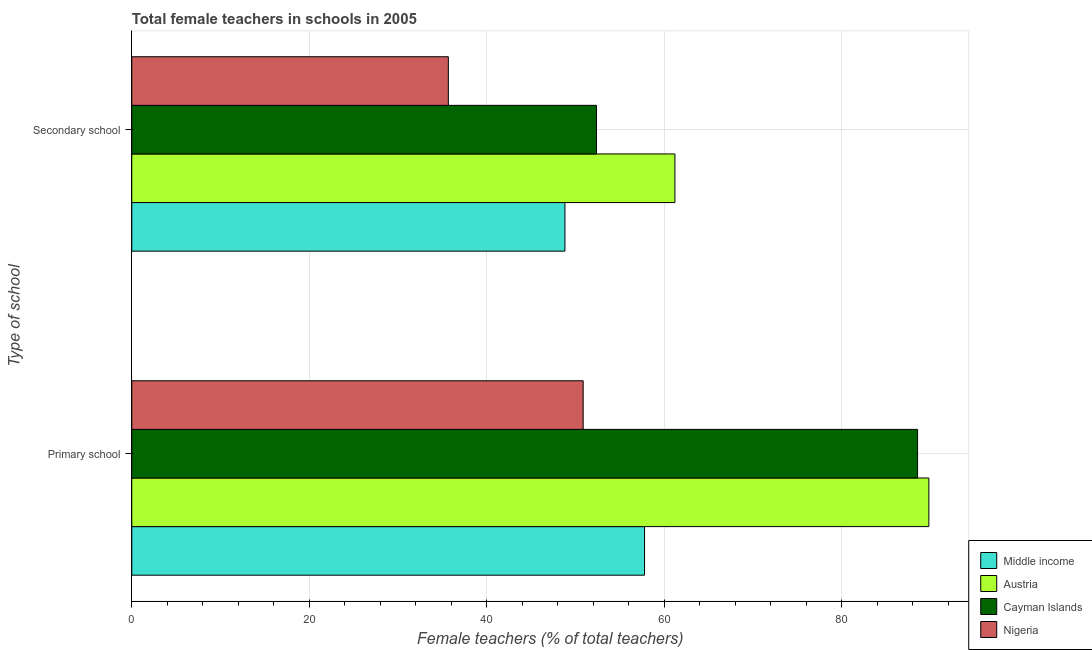How many groups of bars are there?
Offer a terse response. 2. Are the number of bars per tick equal to the number of legend labels?
Provide a succinct answer. Yes. How many bars are there on the 1st tick from the top?
Your answer should be compact. 4. What is the label of the 1st group of bars from the top?
Offer a terse response. Secondary school. What is the percentage of female teachers in primary schools in Nigeria?
Your answer should be compact. 50.86. Across all countries, what is the maximum percentage of female teachers in primary schools?
Offer a terse response. 89.81. Across all countries, what is the minimum percentage of female teachers in primary schools?
Provide a short and direct response. 50.86. In which country was the percentage of female teachers in primary schools minimum?
Provide a succinct answer. Nigeria. What is the total percentage of female teachers in primary schools in the graph?
Ensure brevity in your answer.  286.98. What is the difference between the percentage of female teachers in secondary schools in Middle income and that in Nigeria?
Offer a terse response. 13.14. What is the difference between the percentage of female teachers in secondary schools in Cayman Islands and the percentage of female teachers in primary schools in Nigeria?
Keep it short and to the point. 1.5. What is the average percentage of female teachers in secondary schools per country?
Provide a short and direct response. 49.51. What is the difference between the percentage of female teachers in secondary schools and percentage of female teachers in primary schools in Nigeria?
Offer a terse response. -15.19. In how many countries, is the percentage of female teachers in primary schools greater than 20 %?
Offer a very short reply. 4. What is the ratio of the percentage of female teachers in secondary schools in Nigeria to that in Cayman Islands?
Your response must be concise. 0.68. In how many countries, is the percentage of female teachers in primary schools greater than the average percentage of female teachers in primary schools taken over all countries?
Ensure brevity in your answer.  2. What does the 1st bar from the top in Secondary school represents?
Provide a succinct answer. Nigeria. How many countries are there in the graph?
Keep it short and to the point. 4. What is the difference between two consecutive major ticks on the X-axis?
Make the answer very short. 20. Does the graph contain grids?
Your response must be concise. Yes. How many legend labels are there?
Offer a very short reply. 4. What is the title of the graph?
Ensure brevity in your answer.  Total female teachers in schools in 2005. What is the label or title of the X-axis?
Your response must be concise. Female teachers (% of total teachers). What is the label or title of the Y-axis?
Provide a succinct answer. Type of school. What is the Female teachers (% of total teachers) in Middle income in Primary school?
Your response must be concise. 57.77. What is the Female teachers (% of total teachers) in Austria in Primary school?
Ensure brevity in your answer.  89.81. What is the Female teachers (% of total teachers) in Cayman Islands in Primary school?
Make the answer very short. 88.54. What is the Female teachers (% of total teachers) of Nigeria in Primary school?
Ensure brevity in your answer.  50.86. What is the Female teachers (% of total teachers) in Middle income in Secondary school?
Provide a succinct answer. 48.81. What is the Female teachers (% of total teachers) of Austria in Secondary school?
Make the answer very short. 61.2. What is the Female teachers (% of total teachers) in Cayman Islands in Secondary school?
Keep it short and to the point. 52.36. What is the Female teachers (% of total teachers) in Nigeria in Secondary school?
Offer a terse response. 35.67. Across all Type of school, what is the maximum Female teachers (% of total teachers) in Middle income?
Your response must be concise. 57.77. Across all Type of school, what is the maximum Female teachers (% of total teachers) in Austria?
Make the answer very short. 89.81. Across all Type of school, what is the maximum Female teachers (% of total teachers) of Cayman Islands?
Offer a very short reply. 88.54. Across all Type of school, what is the maximum Female teachers (% of total teachers) of Nigeria?
Keep it short and to the point. 50.86. Across all Type of school, what is the minimum Female teachers (% of total teachers) of Middle income?
Your answer should be compact. 48.81. Across all Type of school, what is the minimum Female teachers (% of total teachers) of Austria?
Offer a terse response. 61.2. Across all Type of school, what is the minimum Female teachers (% of total teachers) in Cayman Islands?
Your answer should be very brief. 52.36. Across all Type of school, what is the minimum Female teachers (% of total teachers) of Nigeria?
Your response must be concise. 35.67. What is the total Female teachers (% of total teachers) in Middle income in the graph?
Make the answer very short. 106.58. What is the total Female teachers (% of total teachers) of Austria in the graph?
Offer a very short reply. 151.01. What is the total Female teachers (% of total teachers) of Cayman Islands in the graph?
Your answer should be very brief. 140.9. What is the total Female teachers (% of total teachers) in Nigeria in the graph?
Give a very brief answer. 86.53. What is the difference between the Female teachers (% of total teachers) of Middle income in Primary school and that in Secondary school?
Keep it short and to the point. 8.97. What is the difference between the Female teachers (% of total teachers) in Austria in Primary school and that in Secondary school?
Provide a succinct answer. 28.61. What is the difference between the Female teachers (% of total teachers) in Cayman Islands in Primary school and that in Secondary school?
Your response must be concise. 36.17. What is the difference between the Female teachers (% of total teachers) in Nigeria in Primary school and that in Secondary school?
Provide a succinct answer. 15.19. What is the difference between the Female teachers (% of total teachers) in Middle income in Primary school and the Female teachers (% of total teachers) in Austria in Secondary school?
Keep it short and to the point. -3.42. What is the difference between the Female teachers (% of total teachers) in Middle income in Primary school and the Female teachers (% of total teachers) in Cayman Islands in Secondary school?
Offer a terse response. 5.41. What is the difference between the Female teachers (% of total teachers) of Middle income in Primary school and the Female teachers (% of total teachers) of Nigeria in Secondary school?
Your answer should be compact. 22.11. What is the difference between the Female teachers (% of total teachers) in Austria in Primary school and the Female teachers (% of total teachers) in Cayman Islands in Secondary school?
Keep it short and to the point. 37.44. What is the difference between the Female teachers (% of total teachers) of Austria in Primary school and the Female teachers (% of total teachers) of Nigeria in Secondary school?
Provide a succinct answer. 54.14. What is the difference between the Female teachers (% of total teachers) in Cayman Islands in Primary school and the Female teachers (% of total teachers) in Nigeria in Secondary school?
Offer a terse response. 52.87. What is the average Female teachers (% of total teachers) in Middle income per Type of school?
Your answer should be very brief. 53.29. What is the average Female teachers (% of total teachers) of Austria per Type of school?
Provide a short and direct response. 75.5. What is the average Female teachers (% of total teachers) of Cayman Islands per Type of school?
Your answer should be very brief. 70.45. What is the average Female teachers (% of total teachers) of Nigeria per Type of school?
Your response must be concise. 43.26. What is the difference between the Female teachers (% of total teachers) of Middle income and Female teachers (% of total teachers) of Austria in Primary school?
Make the answer very short. -32.03. What is the difference between the Female teachers (% of total teachers) of Middle income and Female teachers (% of total teachers) of Cayman Islands in Primary school?
Your answer should be compact. -30.76. What is the difference between the Female teachers (% of total teachers) in Middle income and Female teachers (% of total teachers) in Nigeria in Primary school?
Provide a short and direct response. 6.91. What is the difference between the Female teachers (% of total teachers) in Austria and Female teachers (% of total teachers) in Cayman Islands in Primary school?
Provide a short and direct response. 1.27. What is the difference between the Female teachers (% of total teachers) of Austria and Female teachers (% of total teachers) of Nigeria in Primary school?
Make the answer very short. 38.95. What is the difference between the Female teachers (% of total teachers) in Cayman Islands and Female teachers (% of total teachers) in Nigeria in Primary school?
Keep it short and to the point. 37.68. What is the difference between the Female teachers (% of total teachers) of Middle income and Female teachers (% of total teachers) of Austria in Secondary school?
Offer a very short reply. -12.39. What is the difference between the Female teachers (% of total teachers) of Middle income and Female teachers (% of total teachers) of Cayman Islands in Secondary school?
Offer a very short reply. -3.56. What is the difference between the Female teachers (% of total teachers) in Middle income and Female teachers (% of total teachers) in Nigeria in Secondary school?
Keep it short and to the point. 13.14. What is the difference between the Female teachers (% of total teachers) of Austria and Female teachers (% of total teachers) of Cayman Islands in Secondary school?
Offer a terse response. 8.83. What is the difference between the Female teachers (% of total teachers) of Austria and Female teachers (% of total teachers) of Nigeria in Secondary school?
Make the answer very short. 25.53. What is the difference between the Female teachers (% of total teachers) of Cayman Islands and Female teachers (% of total teachers) of Nigeria in Secondary school?
Give a very brief answer. 16.7. What is the ratio of the Female teachers (% of total teachers) of Middle income in Primary school to that in Secondary school?
Make the answer very short. 1.18. What is the ratio of the Female teachers (% of total teachers) in Austria in Primary school to that in Secondary school?
Provide a short and direct response. 1.47. What is the ratio of the Female teachers (% of total teachers) in Cayman Islands in Primary school to that in Secondary school?
Provide a succinct answer. 1.69. What is the ratio of the Female teachers (% of total teachers) of Nigeria in Primary school to that in Secondary school?
Keep it short and to the point. 1.43. What is the difference between the highest and the second highest Female teachers (% of total teachers) in Middle income?
Provide a short and direct response. 8.97. What is the difference between the highest and the second highest Female teachers (% of total teachers) in Austria?
Provide a succinct answer. 28.61. What is the difference between the highest and the second highest Female teachers (% of total teachers) of Cayman Islands?
Ensure brevity in your answer.  36.17. What is the difference between the highest and the second highest Female teachers (% of total teachers) in Nigeria?
Your response must be concise. 15.19. What is the difference between the highest and the lowest Female teachers (% of total teachers) of Middle income?
Ensure brevity in your answer.  8.97. What is the difference between the highest and the lowest Female teachers (% of total teachers) in Austria?
Make the answer very short. 28.61. What is the difference between the highest and the lowest Female teachers (% of total teachers) of Cayman Islands?
Your answer should be very brief. 36.17. What is the difference between the highest and the lowest Female teachers (% of total teachers) in Nigeria?
Ensure brevity in your answer.  15.19. 